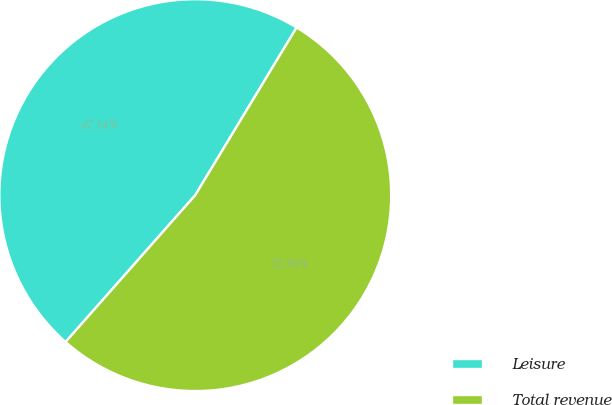Convert chart. <chart><loc_0><loc_0><loc_500><loc_500><pie_chart><fcel>Leisure<fcel>Total revenue<nl><fcel>47.14%<fcel>52.86%<nl></chart> 